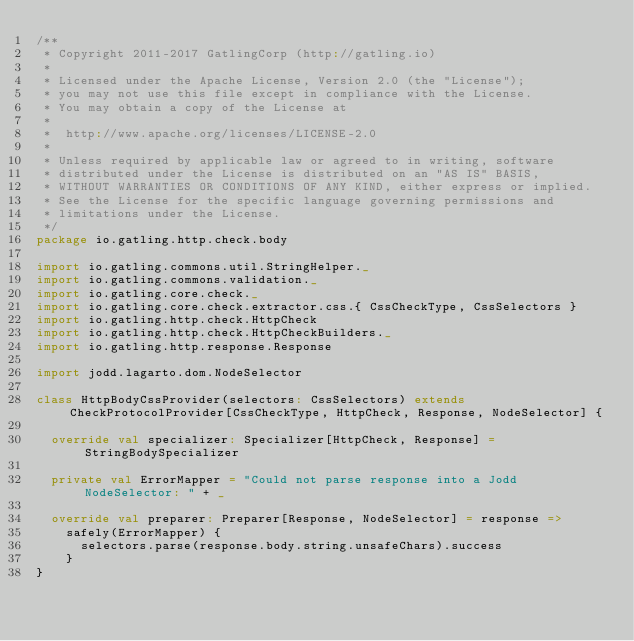<code> <loc_0><loc_0><loc_500><loc_500><_Scala_>/**
 * Copyright 2011-2017 GatlingCorp (http://gatling.io)
 *
 * Licensed under the Apache License, Version 2.0 (the "License");
 * you may not use this file except in compliance with the License.
 * You may obtain a copy of the License at
 *
 *  http://www.apache.org/licenses/LICENSE-2.0
 *
 * Unless required by applicable law or agreed to in writing, software
 * distributed under the License is distributed on an "AS IS" BASIS,
 * WITHOUT WARRANTIES OR CONDITIONS OF ANY KIND, either express or implied.
 * See the License for the specific language governing permissions and
 * limitations under the License.
 */
package io.gatling.http.check.body

import io.gatling.commons.util.StringHelper._
import io.gatling.commons.validation._
import io.gatling.core.check._
import io.gatling.core.check.extractor.css.{ CssCheckType, CssSelectors }
import io.gatling.http.check.HttpCheck
import io.gatling.http.check.HttpCheckBuilders._
import io.gatling.http.response.Response

import jodd.lagarto.dom.NodeSelector

class HttpBodyCssProvider(selectors: CssSelectors) extends CheckProtocolProvider[CssCheckType, HttpCheck, Response, NodeSelector] {

  override val specializer: Specializer[HttpCheck, Response] = StringBodySpecializer

  private val ErrorMapper = "Could not parse response into a Jodd NodeSelector: " + _

  override val preparer: Preparer[Response, NodeSelector] = response =>
    safely(ErrorMapper) {
      selectors.parse(response.body.string.unsafeChars).success
    }
}
</code> 